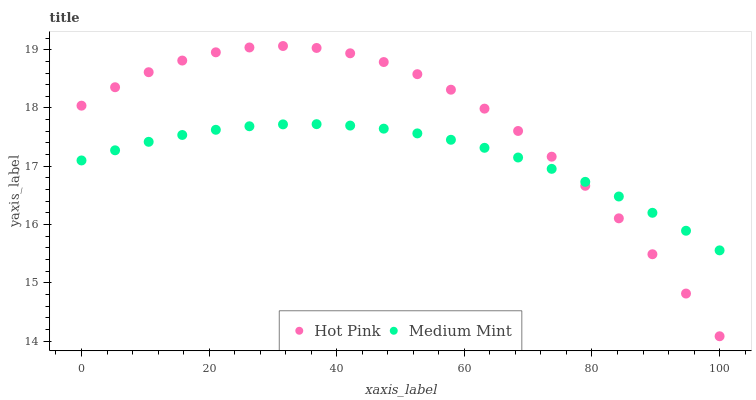Does Medium Mint have the minimum area under the curve?
Answer yes or no. Yes. Does Hot Pink have the maximum area under the curve?
Answer yes or no. Yes. Does Hot Pink have the minimum area under the curve?
Answer yes or no. No. Is Medium Mint the smoothest?
Answer yes or no. Yes. Is Hot Pink the roughest?
Answer yes or no. Yes. Is Hot Pink the smoothest?
Answer yes or no. No. Does Hot Pink have the lowest value?
Answer yes or no. Yes. Does Hot Pink have the highest value?
Answer yes or no. Yes. Does Medium Mint intersect Hot Pink?
Answer yes or no. Yes. Is Medium Mint less than Hot Pink?
Answer yes or no. No. Is Medium Mint greater than Hot Pink?
Answer yes or no. No. 